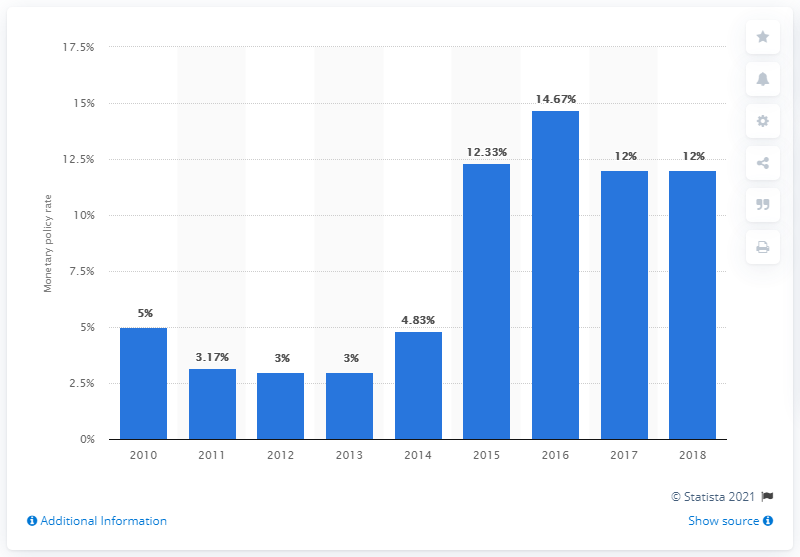List a handful of essential elements in this visual. In 2016, the base interest rate in Haiti was 14.67%. The base interest rate is 14.67... 